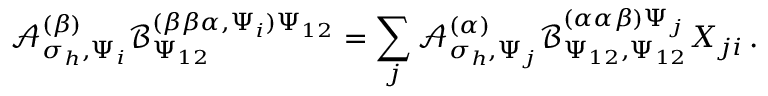Convert formula to latex. <formula><loc_0><loc_0><loc_500><loc_500>\mathcal { A } _ { \sigma _ { h } , \Psi _ { i } } ^ { ( \beta ) } \mathcal { B } _ { \Psi _ { 1 2 } } ^ { ( \beta \beta \alpha , \Psi _ { i } ) \Psi _ { 1 2 } } = \sum _ { j } \mathcal { A } _ { \sigma _ { h } , \Psi _ { j } } ^ { ( \alpha ) } \mathcal { B } _ { \Psi _ { 1 2 } , \Psi _ { 1 2 } } ^ { ( \alpha \alpha \beta ) \Psi _ { j } } X _ { j i } \, .</formula> 